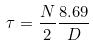<formula> <loc_0><loc_0><loc_500><loc_500>\tau = \frac { N } { 2 } \frac { 8 . 6 9 } { D }</formula> 